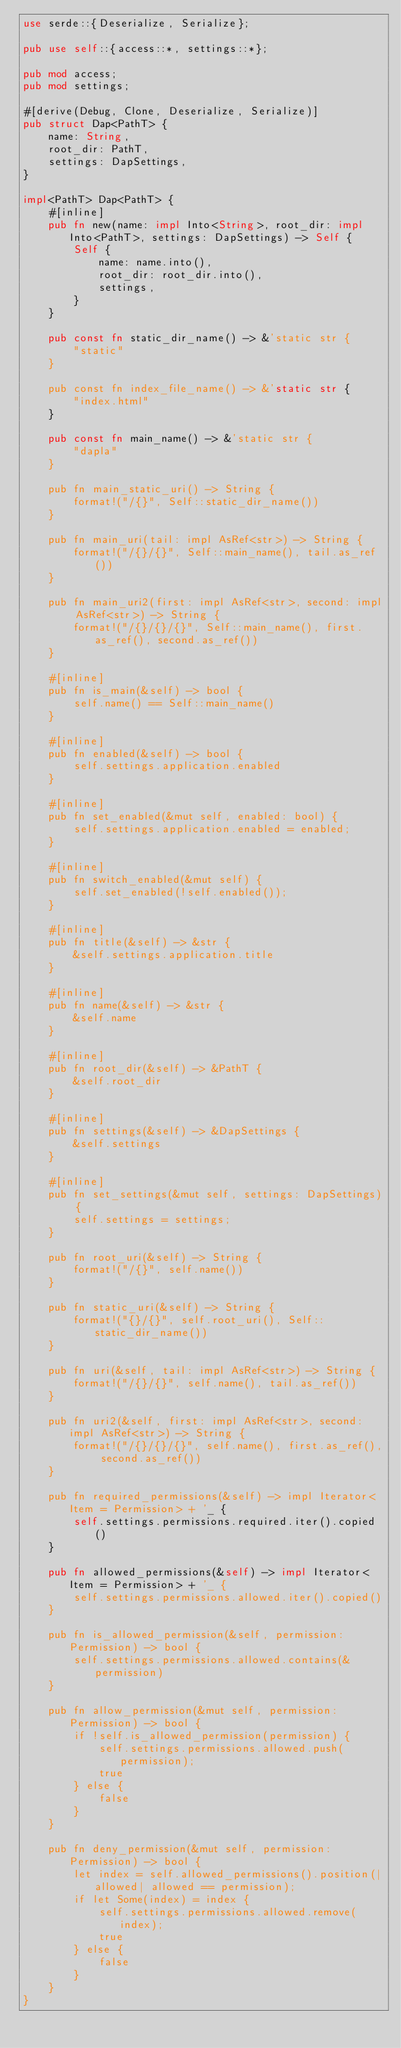<code> <loc_0><loc_0><loc_500><loc_500><_Rust_>use serde::{Deserialize, Serialize};

pub use self::{access::*, settings::*};

pub mod access;
pub mod settings;

#[derive(Debug, Clone, Deserialize, Serialize)]
pub struct Dap<PathT> {
    name: String,
    root_dir: PathT,
    settings: DapSettings,
}

impl<PathT> Dap<PathT> {
    #[inline]
    pub fn new(name: impl Into<String>, root_dir: impl Into<PathT>, settings: DapSettings) -> Self {
        Self {
            name: name.into(),
            root_dir: root_dir.into(),
            settings,
        }
    }

    pub const fn static_dir_name() -> &'static str {
        "static"
    }

    pub const fn index_file_name() -> &'static str {
        "index.html"
    }

    pub const fn main_name() -> &'static str {
        "dapla"
    }

    pub fn main_static_uri() -> String {
        format!("/{}", Self::static_dir_name())
    }

    pub fn main_uri(tail: impl AsRef<str>) -> String {
        format!("/{}/{}", Self::main_name(), tail.as_ref())
    }

    pub fn main_uri2(first: impl AsRef<str>, second: impl AsRef<str>) -> String {
        format!("/{}/{}/{}", Self::main_name(), first.as_ref(), second.as_ref())
    }

    #[inline]
    pub fn is_main(&self) -> bool {
        self.name() == Self::main_name()
    }

    #[inline]
    pub fn enabled(&self) -> bool {
        self.settings.application.enabled
    }

    #[inline]
    pub fn set_enabled(&mut self, enabled: bool) {
        self.settings.application.enabled = enabled;
    }

    #[inline]
    pub fn switch_enabled(&mut self) {
        self.set_enabled(!self.enabled());
    }

    #[inline]
    pub fn title(&self) -> &str {
        &self.settings.application.title
    }

    #[inline]
    pub fn name(&self) -> &str {
        &self.name
    }

    #[inline]
    pub fn root_dir(&self) -> &PathT {
        &self.root_dir
    }

    #[inline]
    pub fn settings(&self) -> &DapSettings {
        &self.settings
    }

    #[inline]
    pub fn set_settings(&mut self, settings: DapSettings) {
        self.settings = settings;
    }

    pub fn root_uri(&self) -> String {
        format!("/{}", self.name())
    }

    pub fn static_uri(&self) -> String {
        format!("{}/{}", self.root_uri(), Self::static_dir_name())
    }

    pub fn uri(&self, tail: impl AsRef<str>) -> String {
        format!("/{}/{}", self.name(), tail.as_ref())
    }

    pub fn uri2(&self, first: impl AsRef<str>, second: impl AsRef<str>) -> String {
        format!("/{}/{}/{}", self.name(), first.as_ref(), second.as_ref())
    }

    pub fn required_permissions(&self) -> impl Iterator<Item = Permission> + '_ {
        self.settings.permissions.required.iter().copied()
    }

    pub fn allowed_permissions(&self) -> impl Iterator<Item = Permission> + '_ {
        self.settings.permissions.allowed.iter().copied()
    }

    pub fn is_allowed_permission(&self, permission: Permission) -> bool {
        self.settings.permissions.allowed.contains(&permission)
    }

    pub fn allow_permission(&mut self, permission: Permission) -> bool {
        if !self.is_allowed_permission(permission) {
            self.settings.permissions.allowed.push(permission);
            true
        } else {
            false
        }
    }

    pub fn deny_permission(&mut self, permission: Permission) -> bool {
        let index = self.allowed_permissions().position(|allowed| allowed == permission);
        if let Some(index) = index {
            self.settings.permissions.allowed.remove(index);
            true
        } else {
            false
        }
    }
}
</code> 